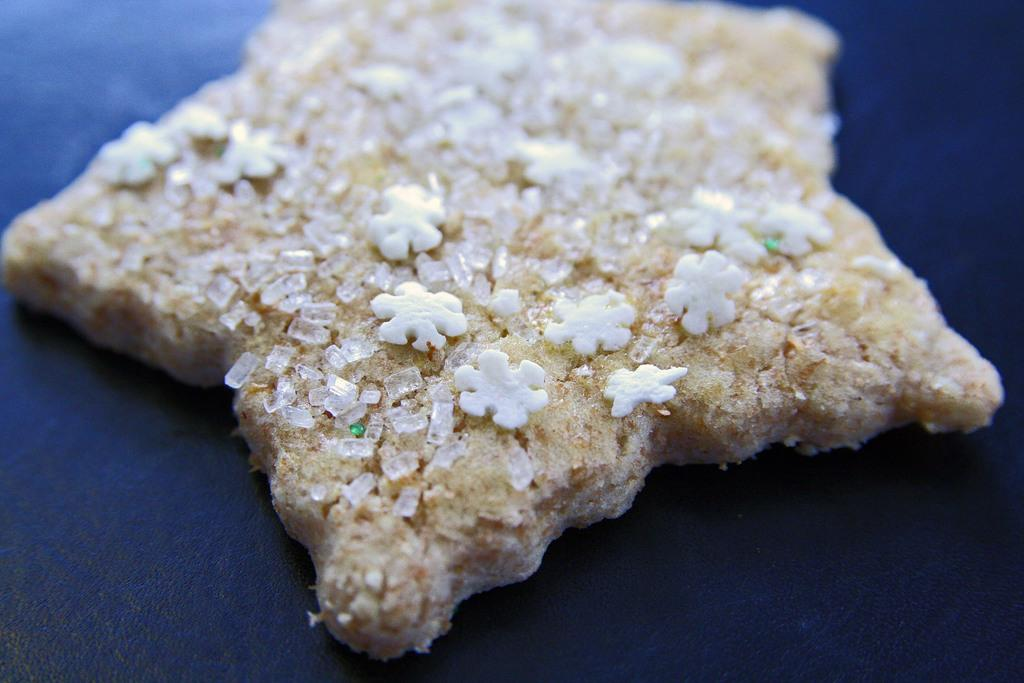What can be seen in the image related to food? There is food visible in the image. Where is the food located in the image? The food is on a surface. How many roses are present in the image? There are no roses visible in the image; it only features food on a surface. 